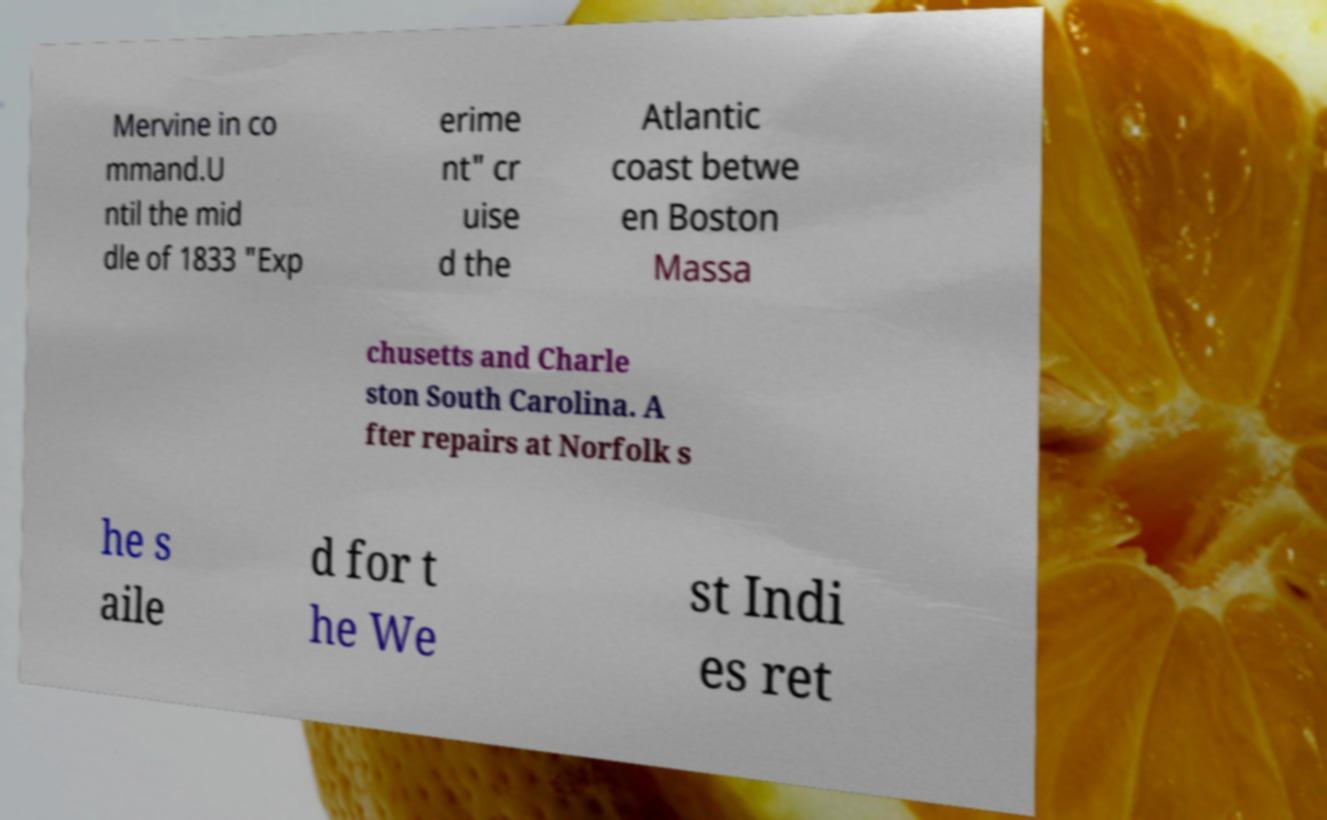For documentation purposes, I need the text within this image transcribed. Could you provide that? Mervine in co mmand.U ntil the mid dle of 1833 "Exp erime nt" cr uise d the Atlantic coast betwe en Boston Massa chusetts and Charle ston South Carolina. A fter repairs at Norfolk s he s aile d for t he We st Indi es ret 